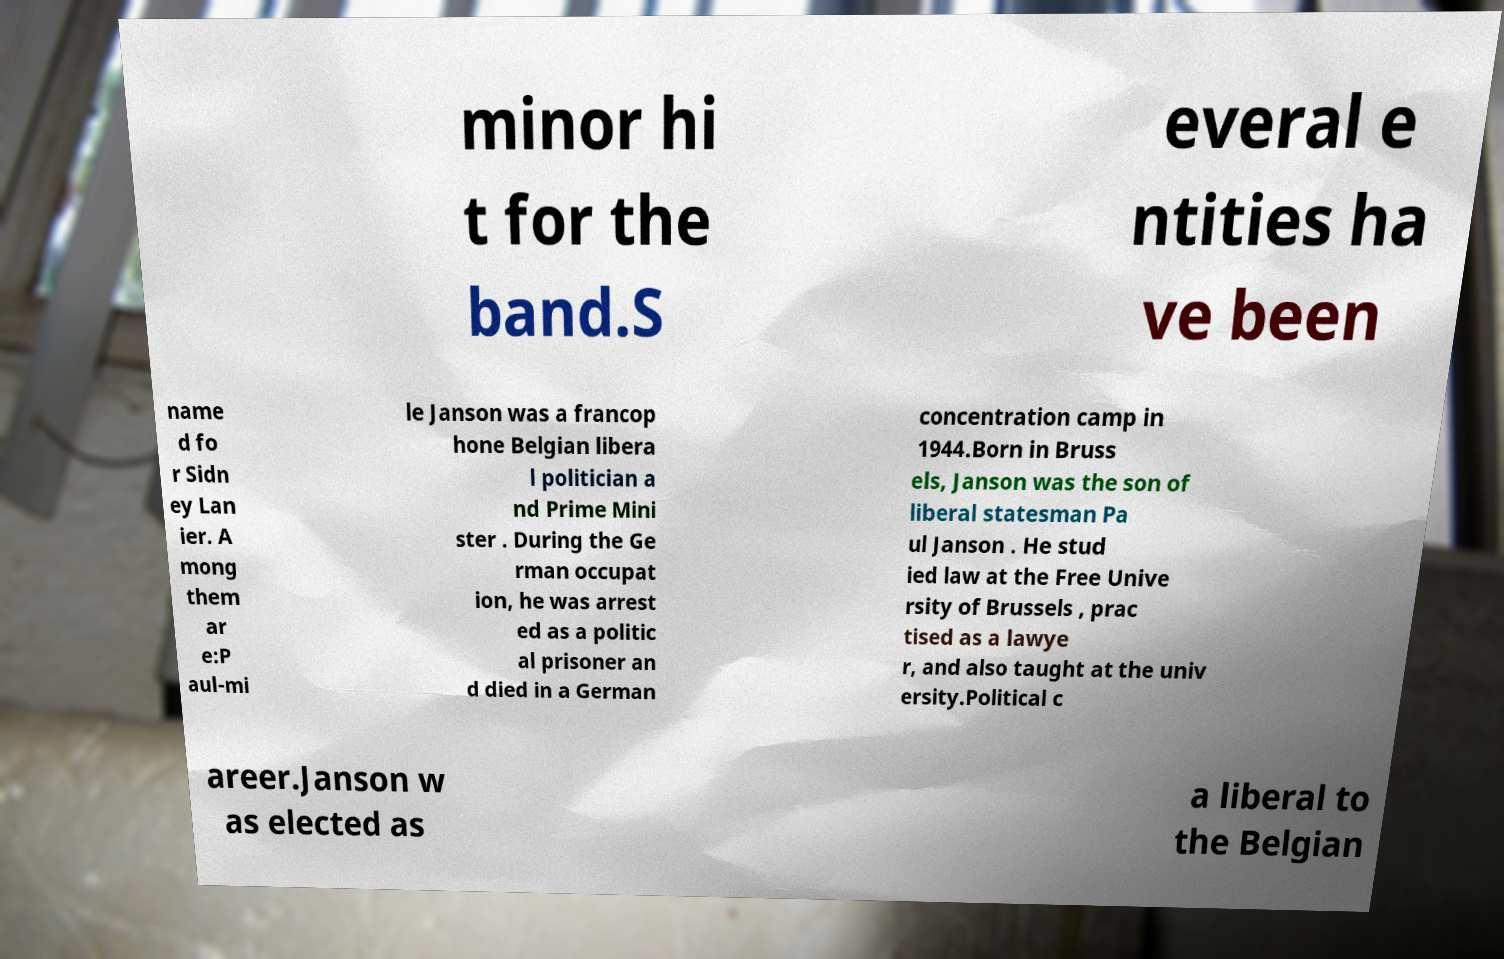Please identify and transcribe the text found in this image. minor hi t for the band.S everal e ntities ha ve been name d fo r Sidn ey Lan ier. A mong them ar e:P aul-mi le Janson was a francop hone Belgian libera l politician a nd Prime Mini ster . During the Ge rman occupat ion, he was arrest ed as a politic al prisoner an d died in a German concentration camp in 1944.Born in Bruss els, Janson was the son of liberal statesman Pa ul Janson . He stud ied law at the Free Unive rsity of Brussels , prac tised as a lawye r, and also taught at the univ ersity.Political c areer.Janson w as elected as a liberal to the Belgian 